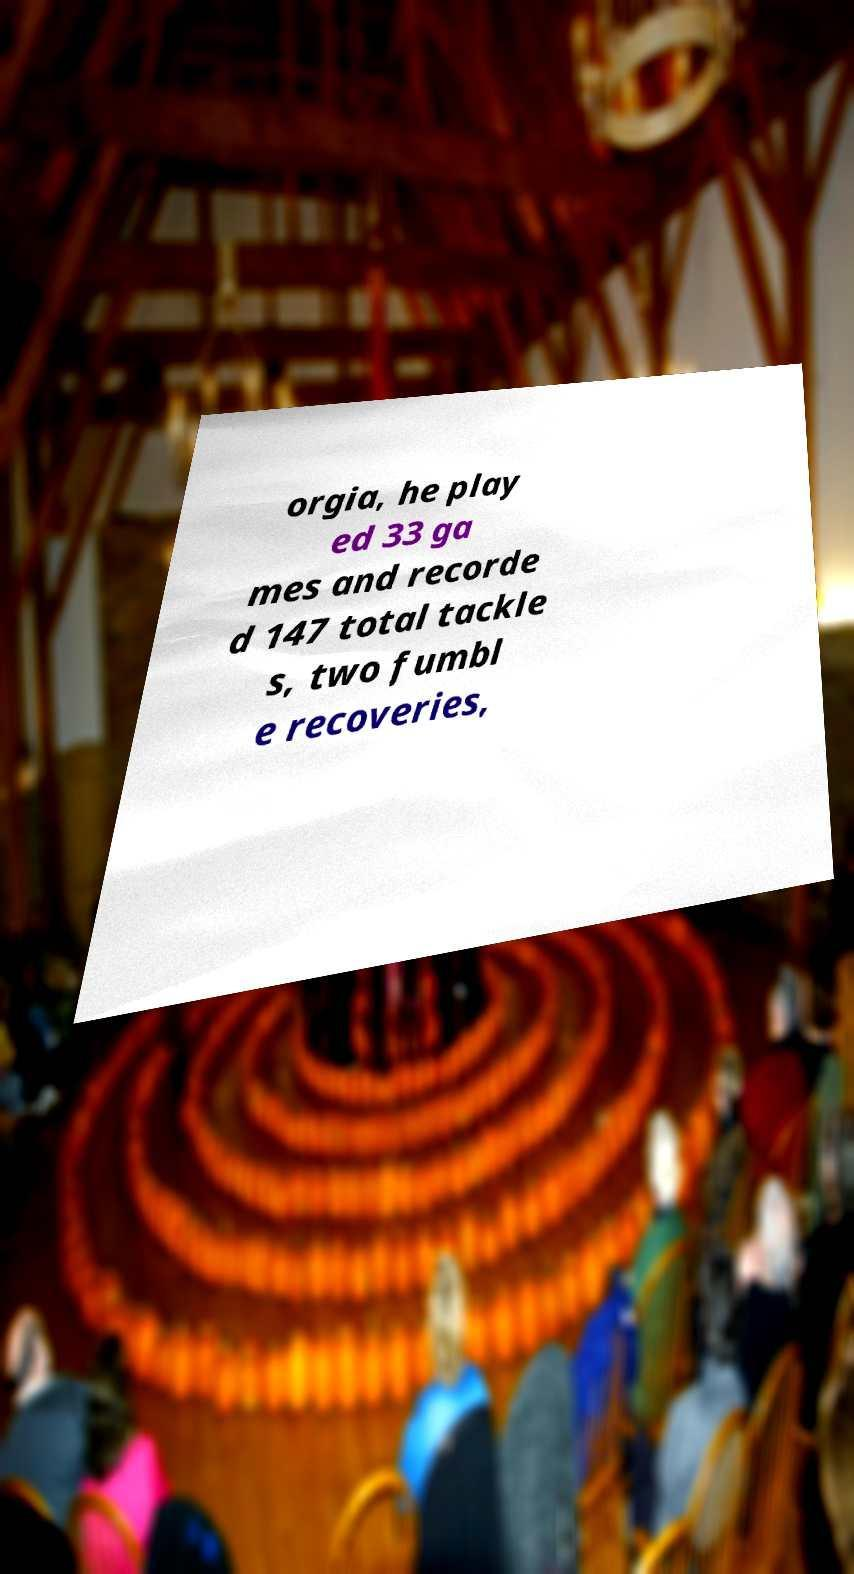Please identify and transcribe the text found in this image. orgia, he play ed 33 ga mes and recorde d 147 total tackle s, two fumbl e recoveries, 